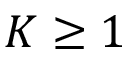Convert formula to latex. <formula><loc_0><loc_0><loc_500><loc_500>K \geq 1</formula> 